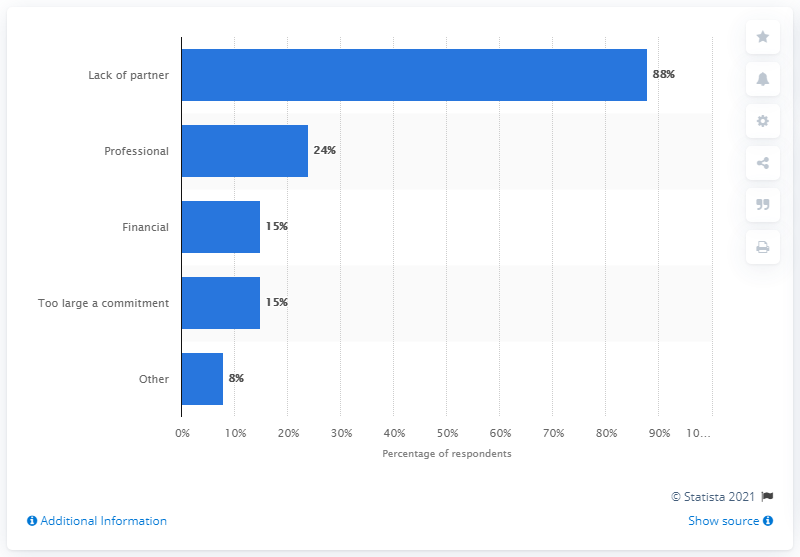List a handful of essential elements in this visual. According to a survey of women in the United States, 88% reported that the lack of a partner was the primary reason for undergoing oocyte cryopreservation. 